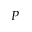Convert formula to latex. <formula><loc_0><loc_0><loc_500><loc_500>P</formula> 